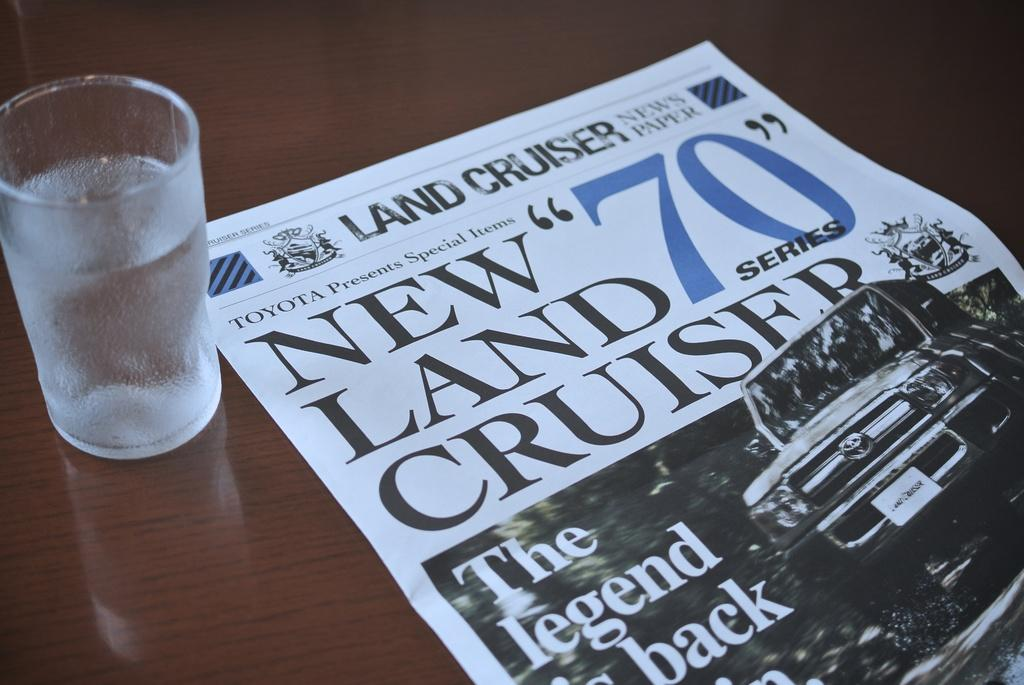<image>
Provide a brief description of the given image. a glass next to a paper that says 'land cruiser' on it 